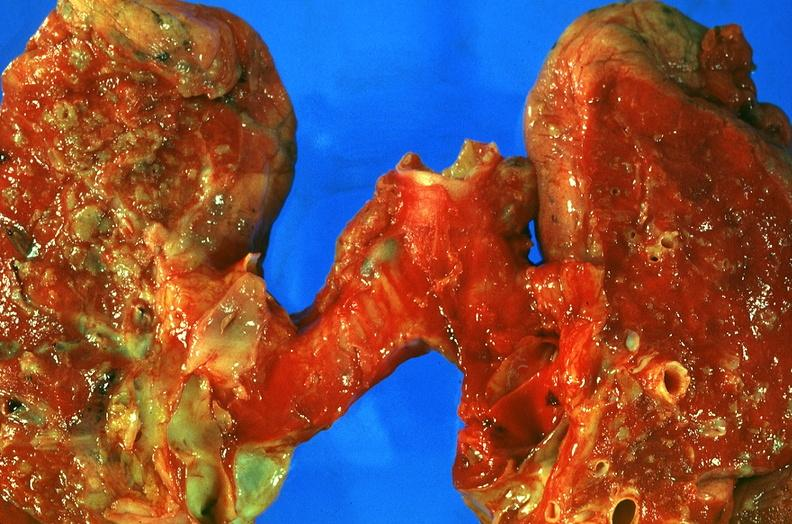does spinal fluid show lung, sarcoidosis?
Answer the question using a single word or phrase. No 